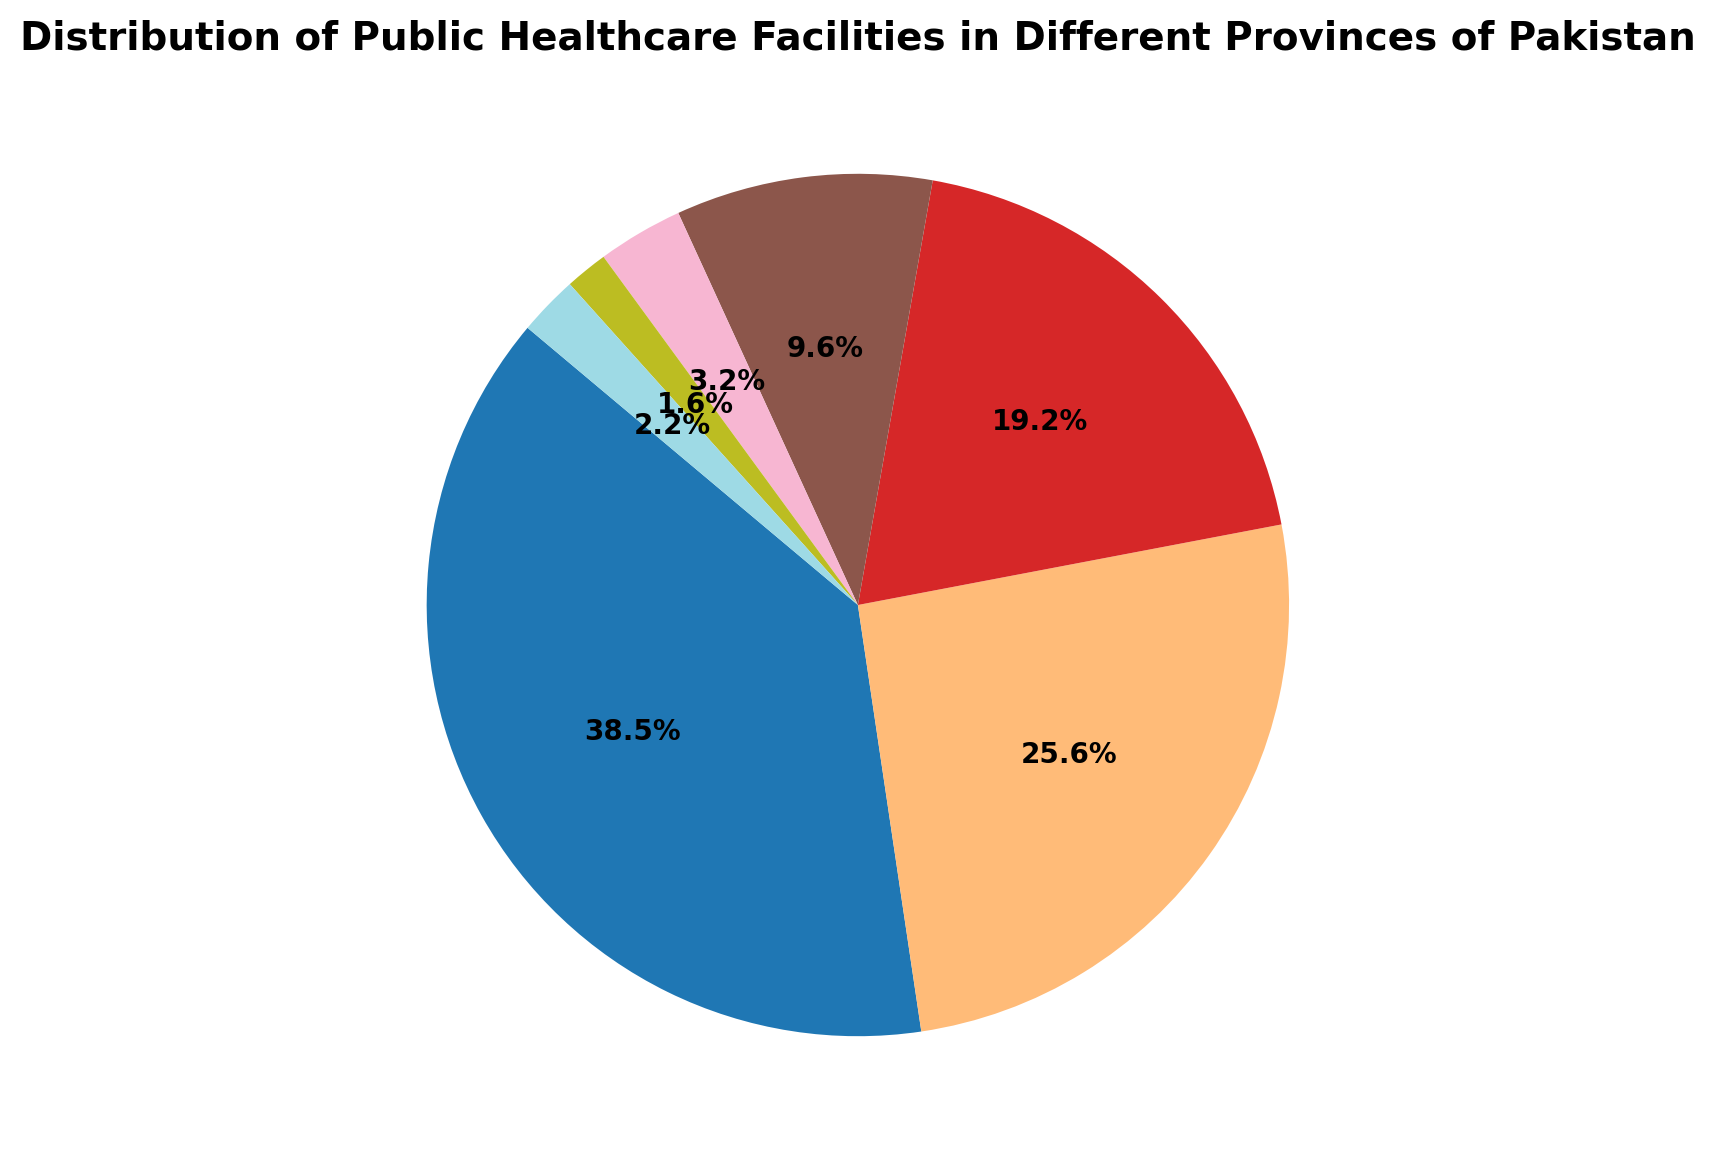What percentage of public healthcare facilities are in Punjab? Look at the slice labeled "Punjab" in the pie chart. The percentage value given for Punjab shows the proportion of healthcare facilities in Punjab out of the total facilities.
Answer: 40.0% Which province has the least number of healthcare facilities? Identify the smallest slice in the pie chart, which represents the province with the least quantity of healthcare facilities. The label on that slice will indicate the province.
Answer: Gilgit-Baltistan What is the combined percentage share of healthcare facilities in Sindh and Khyber Pakhtunkhwa? Find the percentage values for Sindh and Khyber Pakhtunkhwa in the pie chart. Add those two percentages together to get the combined share.
Answer: Sindh (26.7%) + Khyber Pakhtunkhwa (20.0%) = 46.7% How does the percentage of healthcare facilities in Balochistan compare to that in Islamabad? Find the percentages for Balochistan and Islamabad in the pie chart. Compare the two values to determine how they relate to each other.
Answer: Balochistan (10.0%) is greater than Islamabad (3.3%) Which regions have a share of less than 5% of healthcare facilities each? Check the pie chart slices for each region, review their labeled percentage values, and identify those with values less than 5%.
Answer: Islamabad (3.3%), Gilgit-Baltistan (1.7%), Azad Jammu & Kashmir (2.3%) How many provinces have more than 1000 healthcare facilities? Review the labeled values for each province on the pie chart to determine the actual number of facilities, and count how many exceed 1000.
Answer: One (Punjab) 